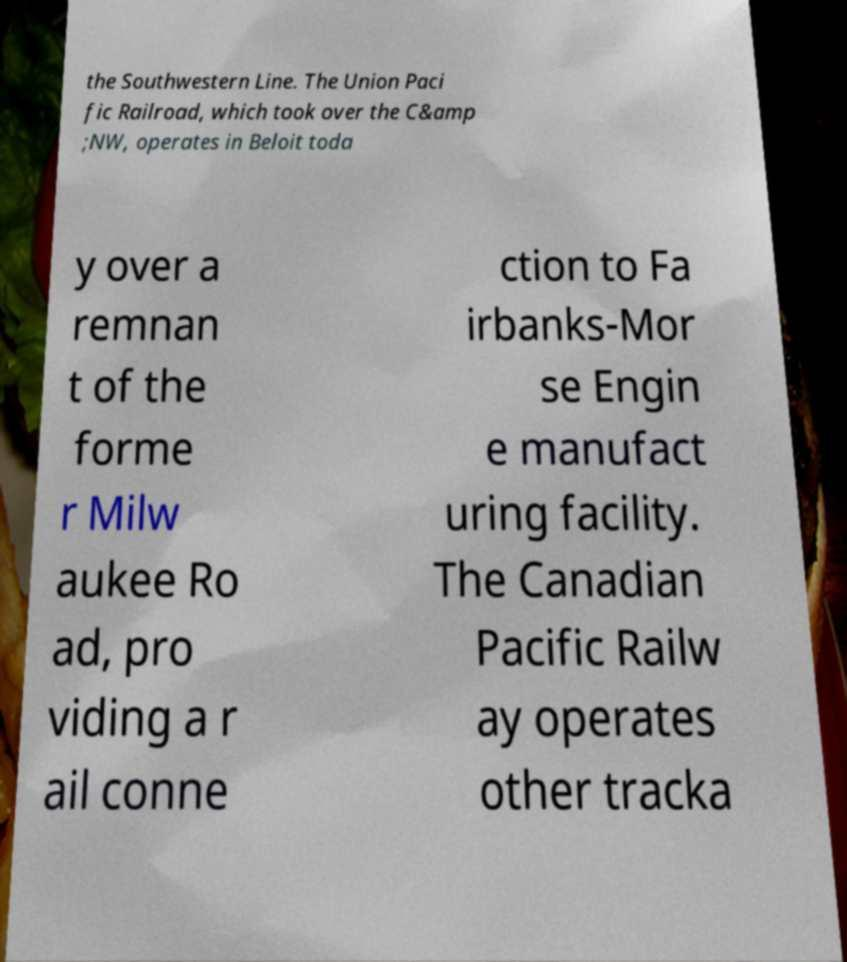For documentation purposes, I need the text within this image transcribed. Could you provide that? the Southwestern Line. The Union Paci fic Railroad, which took over the C&amp ;NW, operates in Beloit toda y over a remnan t of the forme r Milw aukee Ro ad, pro viding a r ail conne ction to Fa irbanks-Mor se Engin e manufact uring facility. The Canadian Pacific Railw ay operates other tracka 